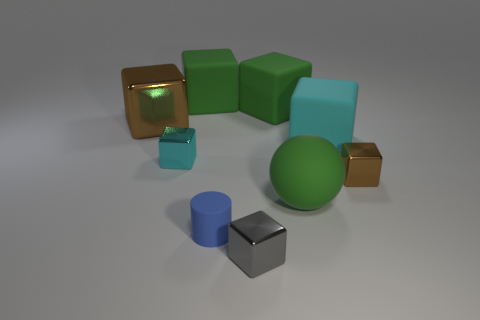Is the size of the brown metallic cube that is left of the small brown cube the same as the green rubber cube that is on the left side of the gray metal thing?
Give a very brief answer. Yes. The rubber ball has what color?
Your answer should be compact. Green. Does the brown metallic thing that is to the right of the gray metal thing have the same shape as the large brown metallic thing?
Provide a short and direct response. Yes. What is the material of the big cyan thing?
Offer a terse response. Rubber. The blue matte object that is the same size as the cyan shiny cube is what shape?
Your answer should be compact. Cylinder. Are there any big rubber cubes of the same color as the big matte ball?
Make the answer very short. Yes. There is a ball; is it the same color as the large matte object to the left of the small rubber thing?
Make the answer very short. Yes. There is a tiny cylinder to the right of the big green matte thing left of the gray block; what color is it?
Make the answer very short. Blue. Are there any big green spheres that are in front of the brown cube left of the cyan object right of the big rubber sphere?
Ensure brevity in your answer.  Yes. What is the color of the small cylinder that is the same material as the green ball?
Your answer should be compact. Blue. 